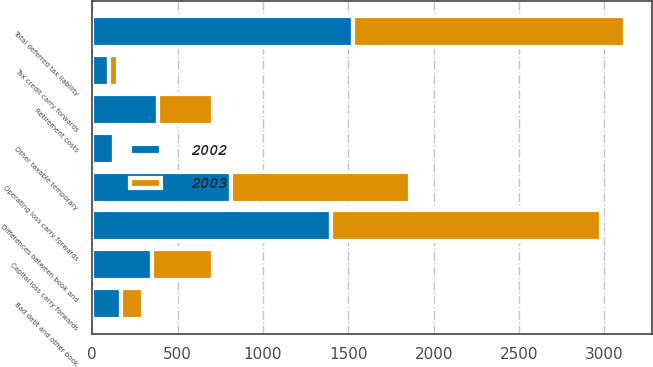Convert chart. <chart><loc_0><loc_0><loc_500><loc_500><stacked_bar_chart><ecel><fcel>Differences between book and<fcel>Other taxable temporary<fcel>Total deferred tax liability<fcel>Operating loss carry forwards<fcel>Capital loss carry forwards<fcel>Bad debt and other book<fcel>Retirement costs<fcel>Tax credit carry forwards<nl><fcel>2003<fcel>1581<fcel>14<fcel>1595<fcel>1047<fcel>358<fcel>132<fcel>321<fcel>53<nl><fcel>2002<fcel>1399<fcel>127<fcel>1526<fcel>814<fcel>348<fcel>167<fcel>388<fcel>96<nl></chart> 